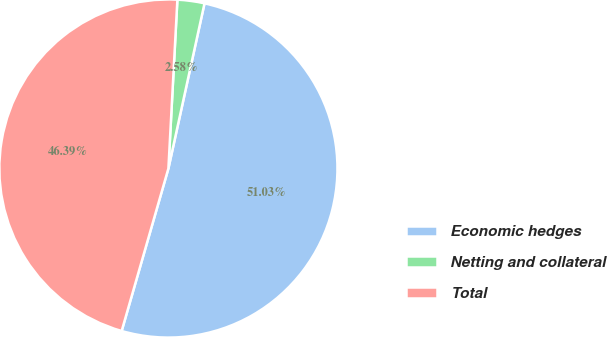Convert chart to OTSL. <chart><loc_0><loc_0><loc_500><loc_500><pie_chart><fcel>Economic hedges<fcel>Netting and collateral<fcel>Total<nl><fcel>51.03%<fcel>2.58%<fcel>46.39%<nl></chart> 